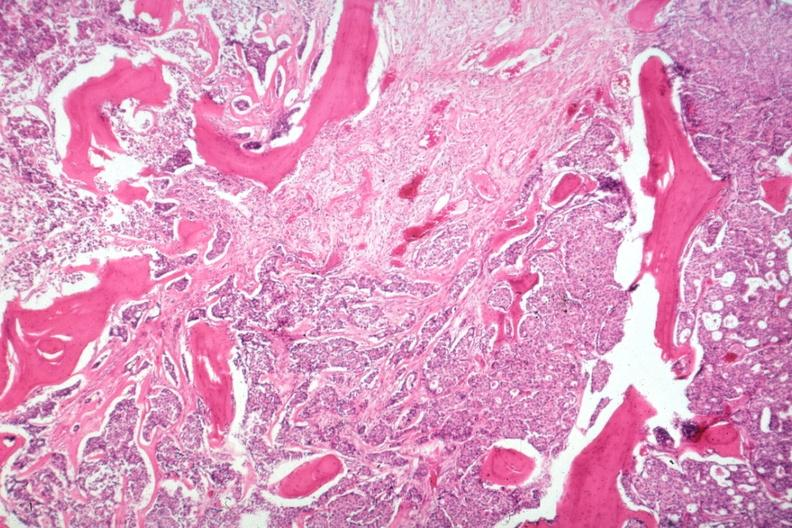how does this image show vertebral body gross is islands of tumor?
Answer the question using a single word or phrase. With stimulated new bone formation a desmoplastic reaction to the additional micros are and 